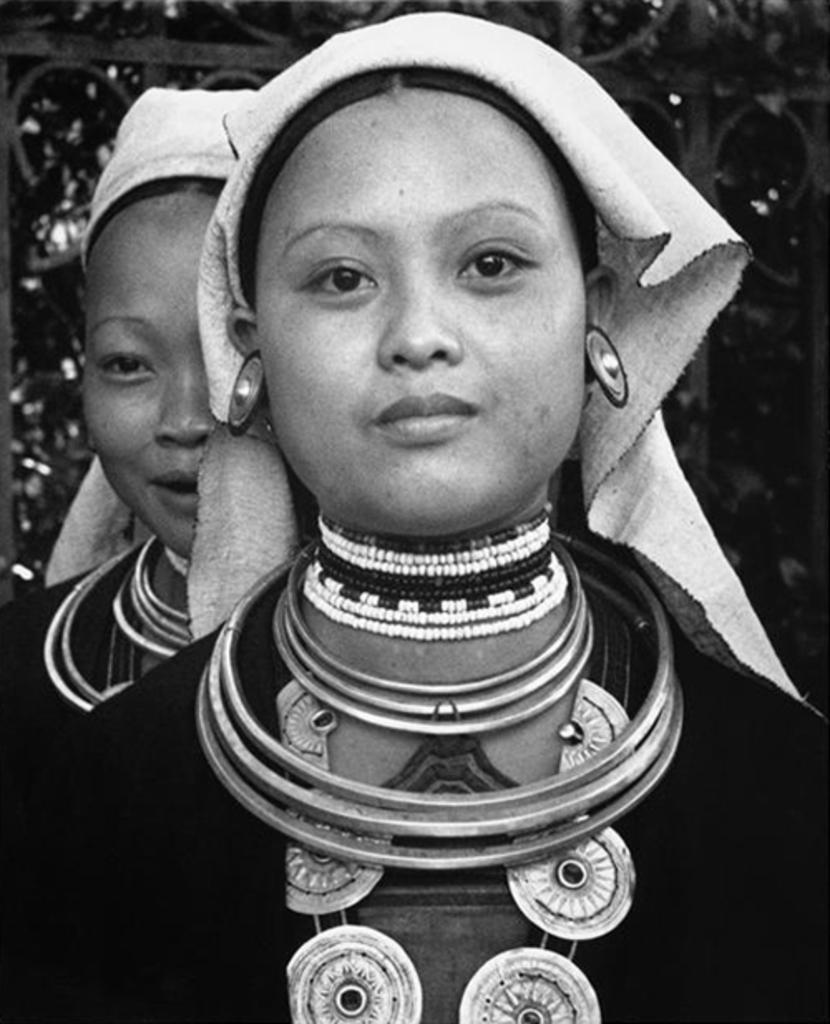How many people are in the image? There are persons standing in the image. What is the facial expression of the persons in the image? The persons are smiling. What can be seen in the background of the image? There is a gate in the background of the image. What type of vegetation is visible behind the gate in the background of the image? Trees are visible behind the gate in the background of the image. What type of iron is being used to make the jam in the image? There is no iron or jam present in the image. How many masses of people can be seen in the image? There is no reference to masses in the image; there are simply persons standing. 